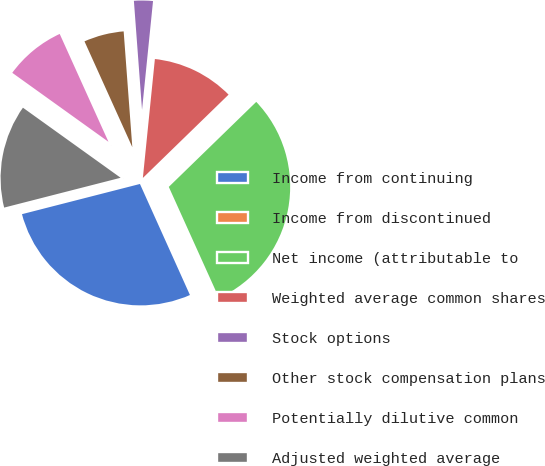<chart> <loc_0><loc_0><loc_500><loc_500><pie_chart><fcel>Income from continuing<fcel>Income from discontinued<fcel>Net income (attributable to<fcel>Weighted average common shares<fcel>Stock options<fcel>Other stock compensation plans<fcel>Potentially dilutive common<fcel>Adjusted weighted average<nl><fcel>27.74%<fcel>0.02%<fcel>30.52%<fcel>11.12%<fcel>2.79%<fcel>5.57%<fcel>8.34%<fcel>13.89%<nl></chart> 